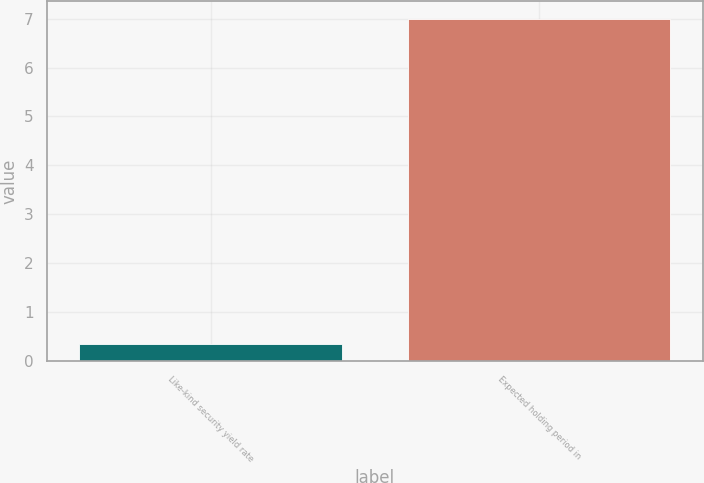<chart> <loc_0><loc_0><loc_500><loc_500><bar_chart><fcel>Like-kind security yield rate<fcel>Expected holding period in<nl><fcel>0.36<fcel>7<nl></chart> 